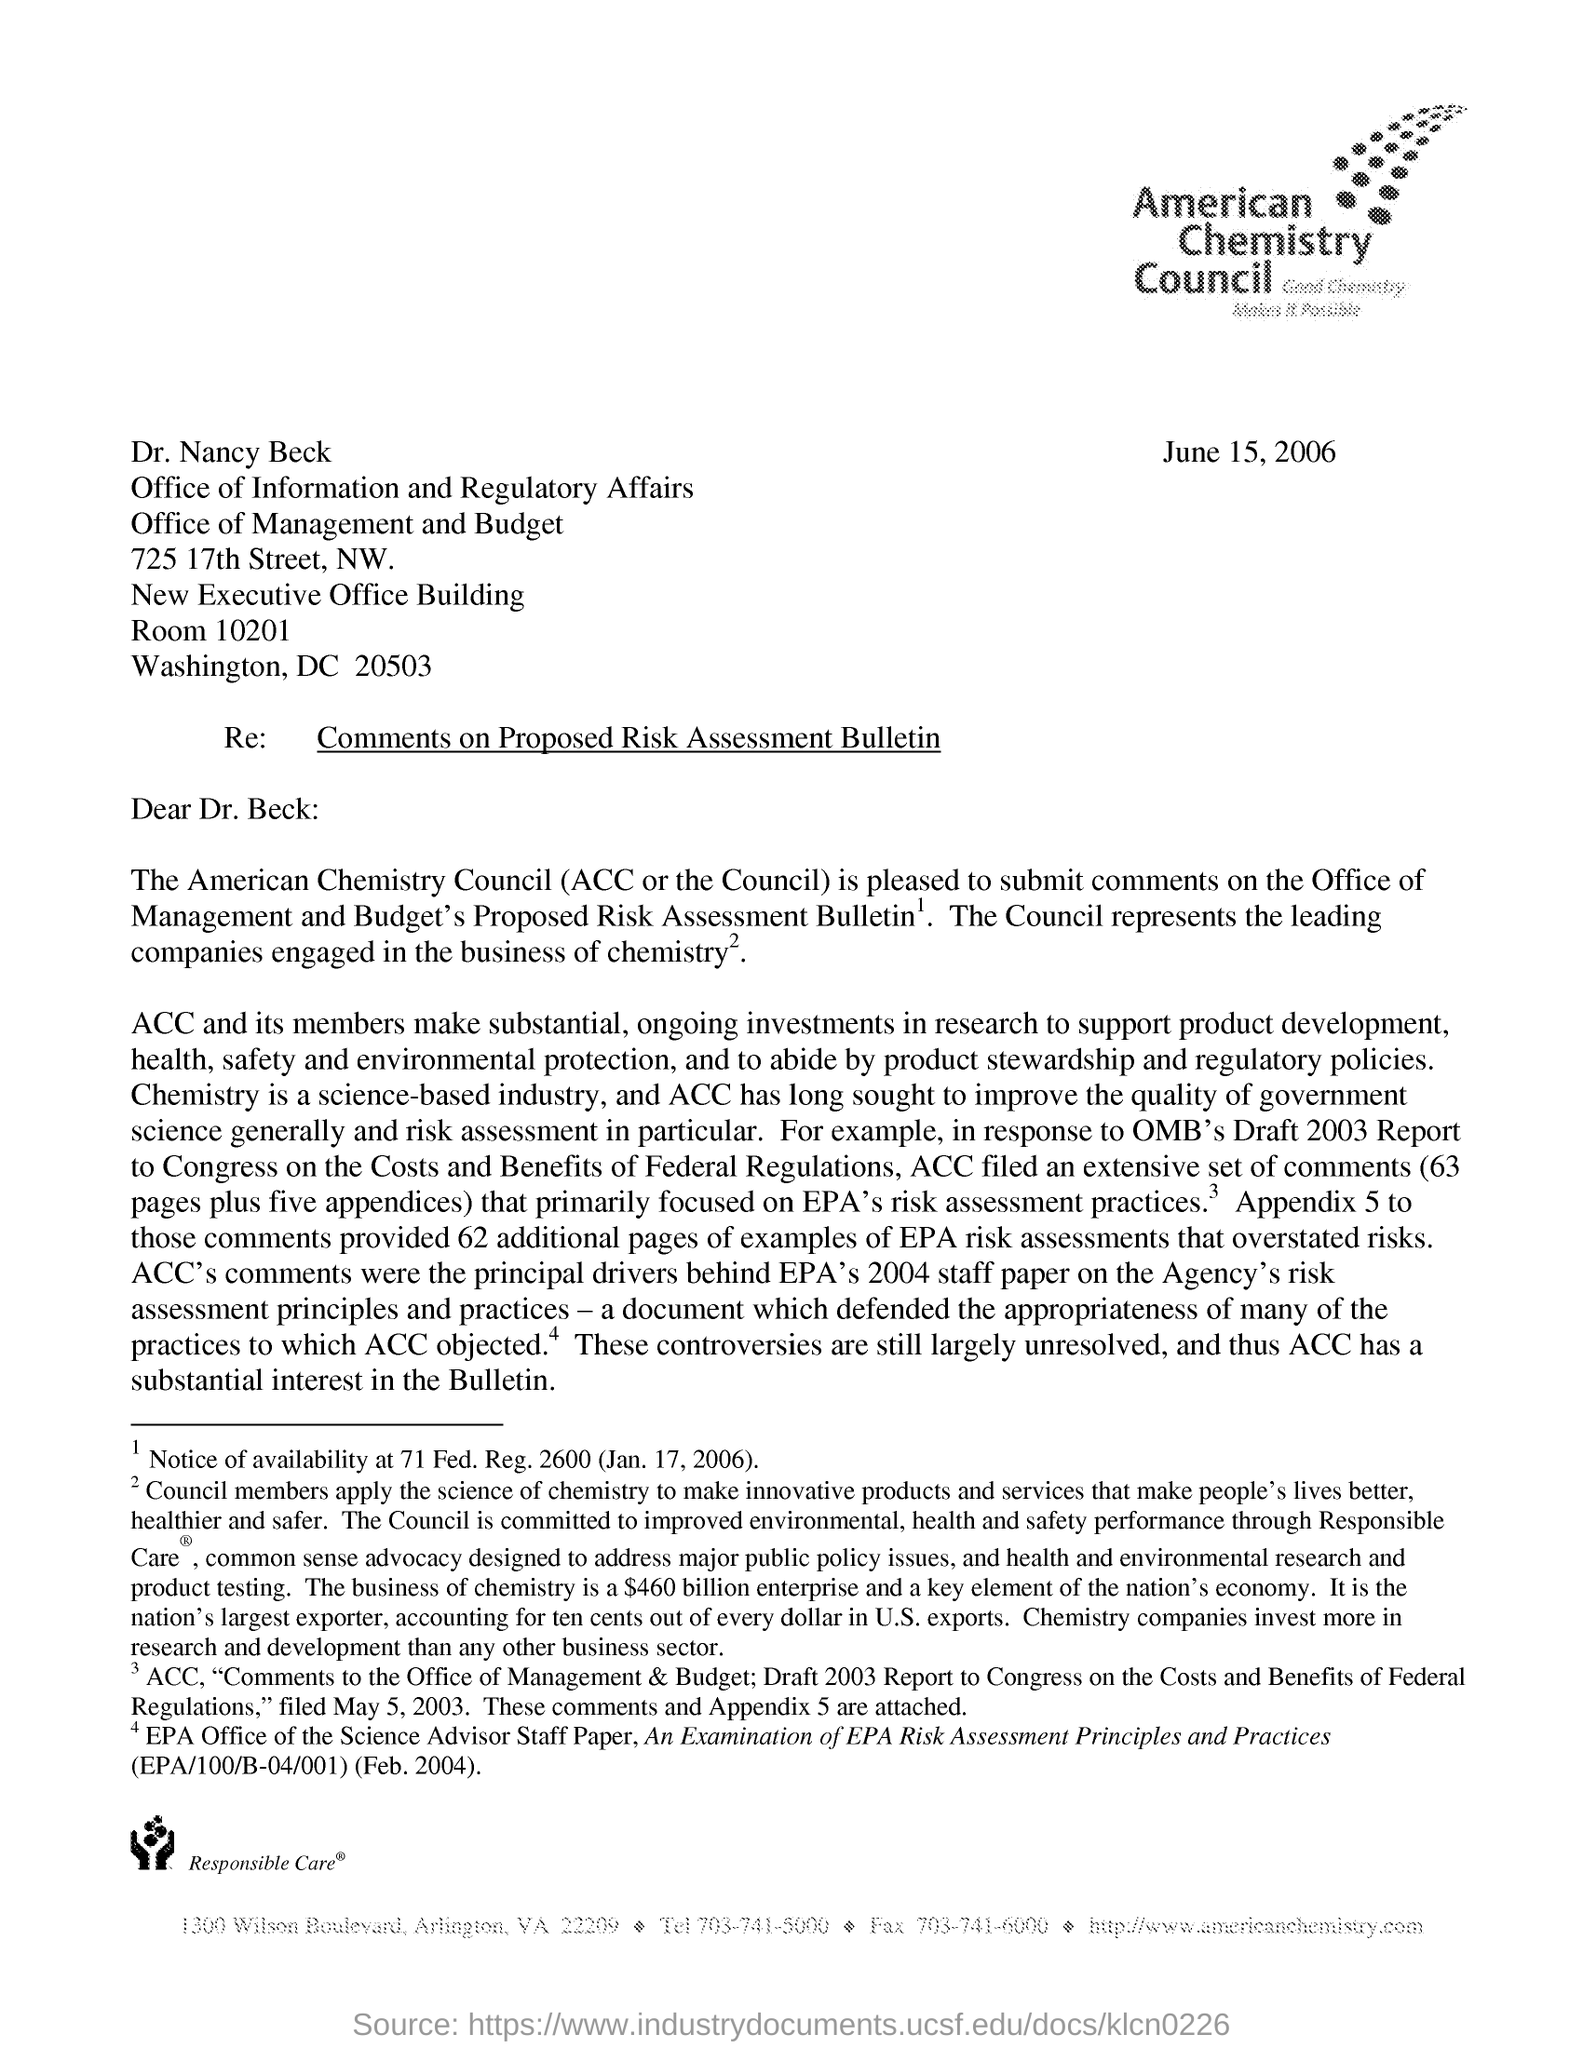Specify some key components in this picture. The American Chemistry Council, commonly referred to as ACC, is an organization that represents the interests of the chemical industry in the United States. The subject of the letter is comments on a proposed risk assessment bulletin. The issued date of this letter is June 15, 2006. 